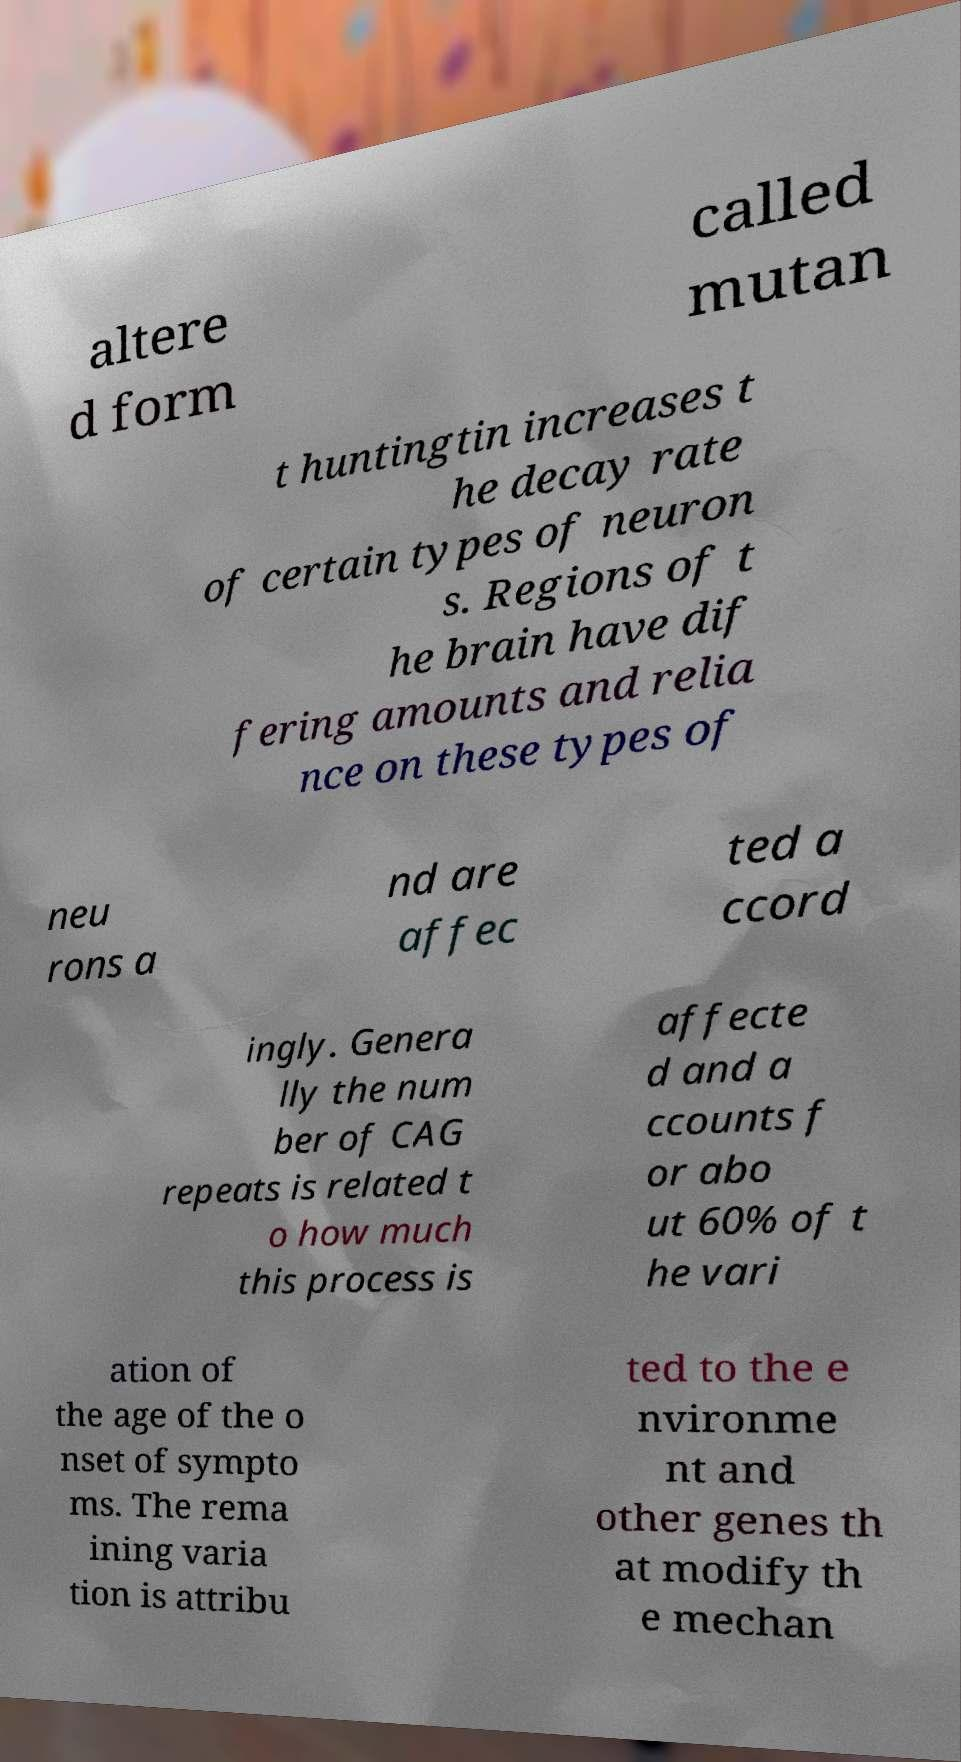I need the written content from this picture converted into text. Can you do that? altere d form called mutan t huntingtin increases t he decay rate of certain types of neuron s. Regions of t he brain have dif fering amounts and relia nce on these types of neu rons a nd are affec ted a ccord ingly. Genera lly the num ber of CAG repeats is related t o how much this process is affecte d and a ccounts f or abo ut 60% of t he vari ation of the age of the o nset of sympto ms. The rema ining varia tion is attribu ted to the e nvironme nt and other genes th at modify th e mechan 